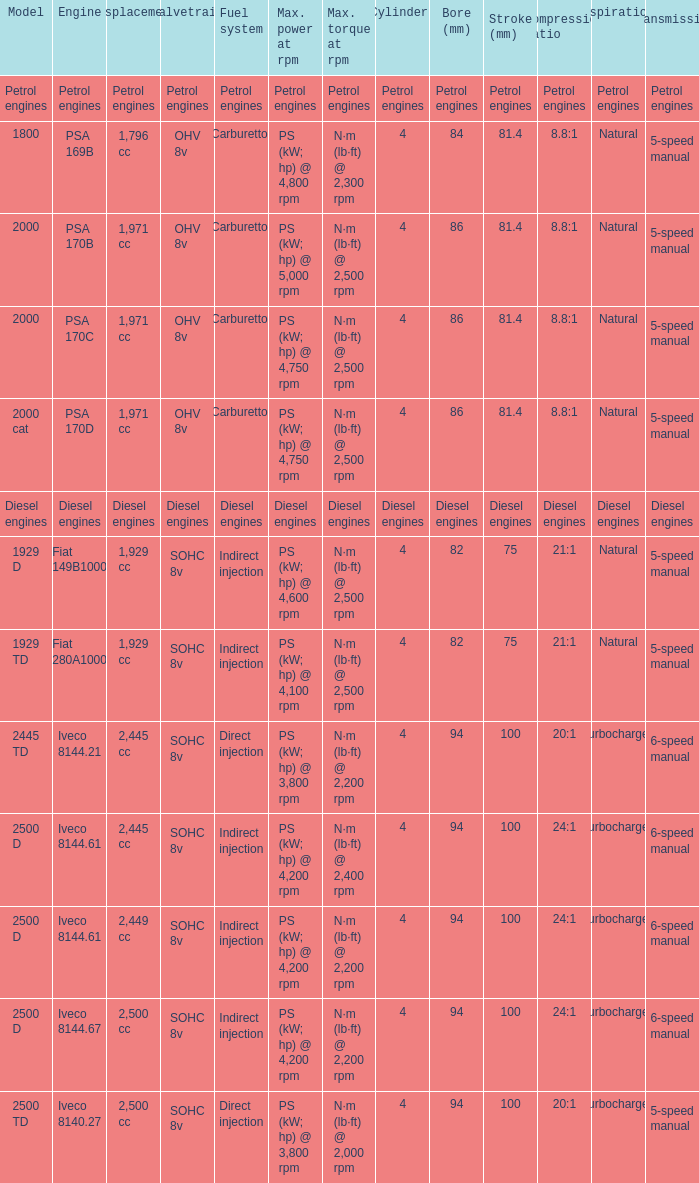What Valvetrain has a fuel system made up of petrol engines? Petrol engines. 